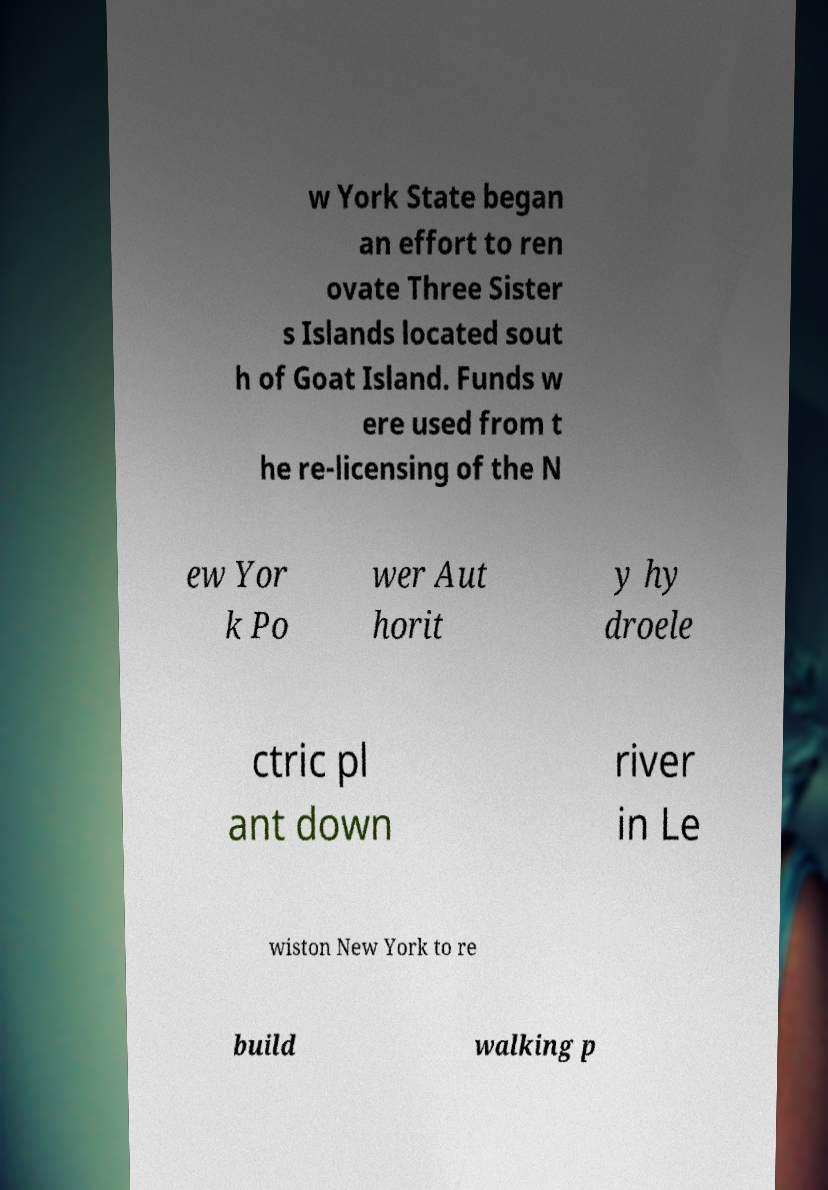Please read and relay the text visible in this image. What does it say? w York State began an effort to ren ovate Three Sister s Islands located sout h of Goat Island. Funds w ere used from t he re-licensing of the N ew Yor k Po wer Aut horit y hy droele ctric pl ant down river in Le wiston New York to re build walking p 